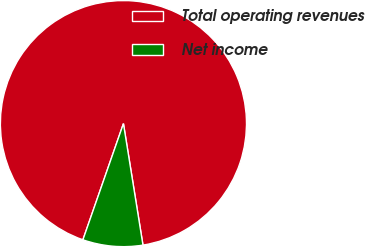Convert chart. <chart><loc_0><loc_0><loc_500><loc_500><pie_chart><fcel>Total operating revenues<fcel>Net income<nl><fcel>92.12%<fcel>7.88%<nl></chart> 